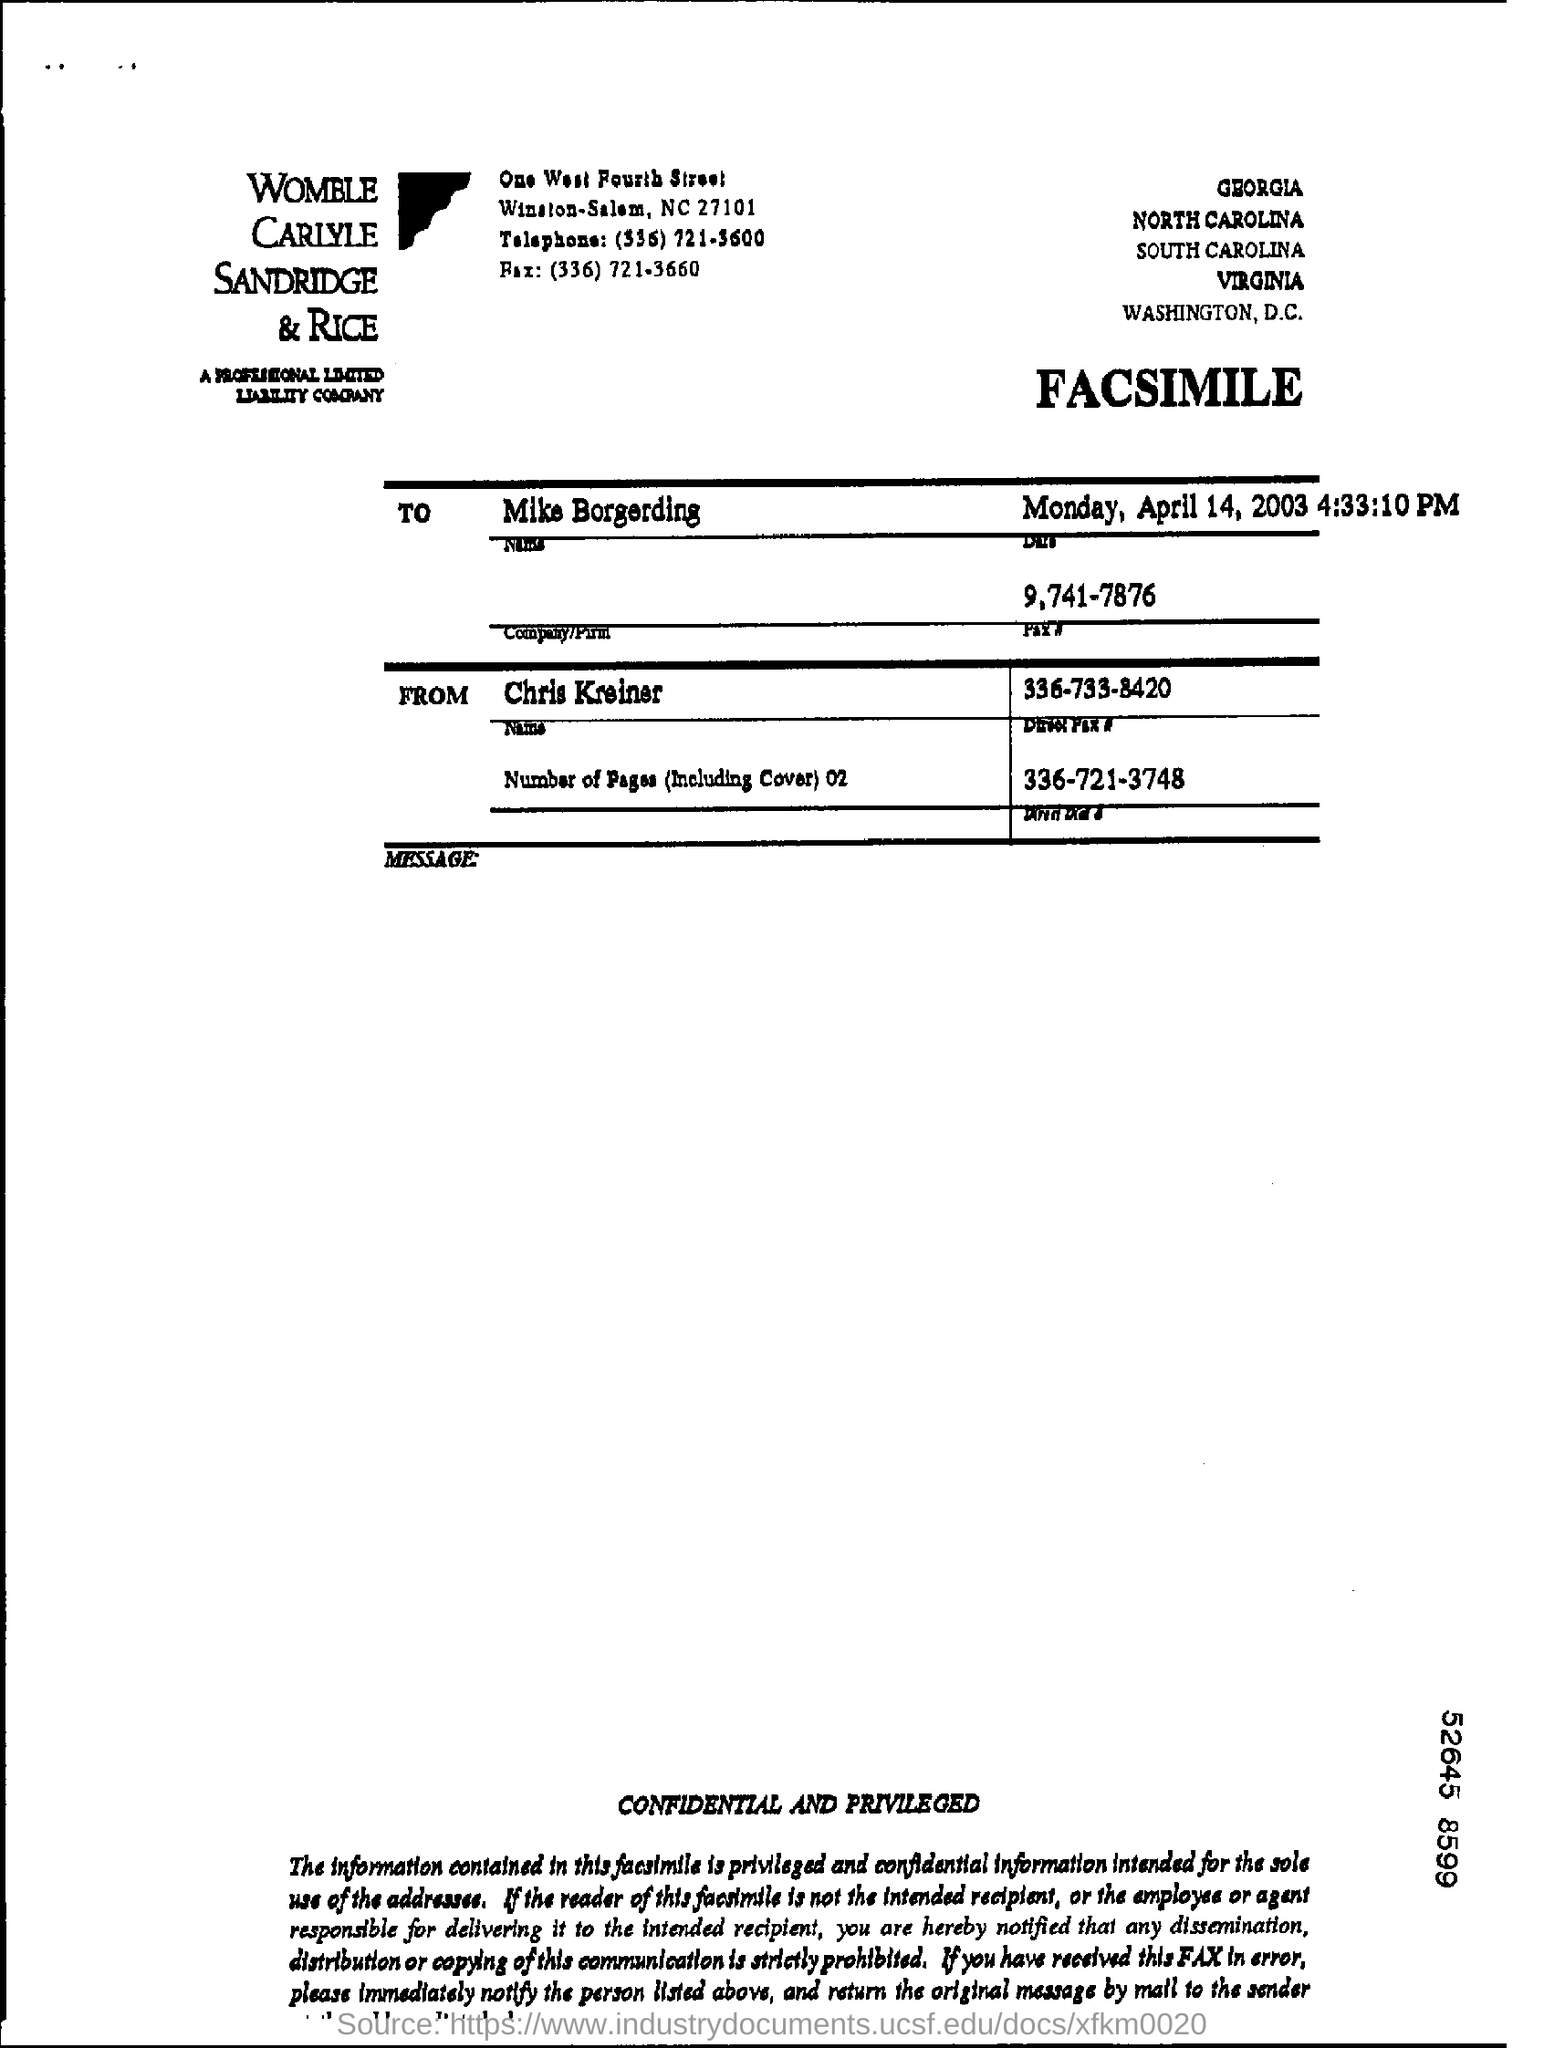To whom is the fax addressed?
Your response must be concise. Mike Borgerding. What is the Fax number of Mike given?
Keep it short and to the point. 9,741-7876. From whom is the fax?
Ensure brevity in your answer.  Chris Kreiner. 